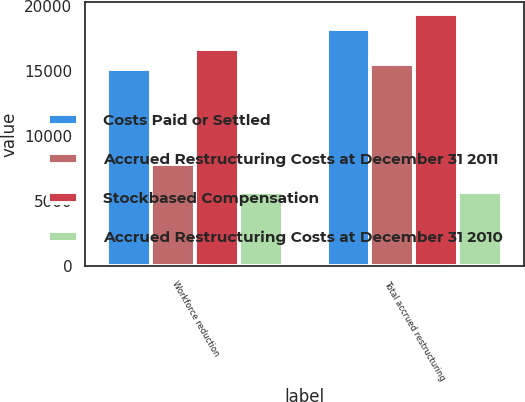Convert chart to OTSL. <chart><loc_0><loc_0><loc_500><loc_500><stacked_bar_chart><ecel><fcel>Workforce reduction<fcel>Total accrued restructuring<nl><fcel>Costs Paid or Settled<fcel>15120<fcel>18221<nl><fcel>Accrued Restructuring Costs at December 31 2011<fcel>7824<fcel>15512<nl><fcel>Stockbased Compensation<fcel>16661<fcel>19347<nl><fcel>Accrued Restructuring Costs at December 31 2010<fcel>5701<fcel>5701<nl></chart> 